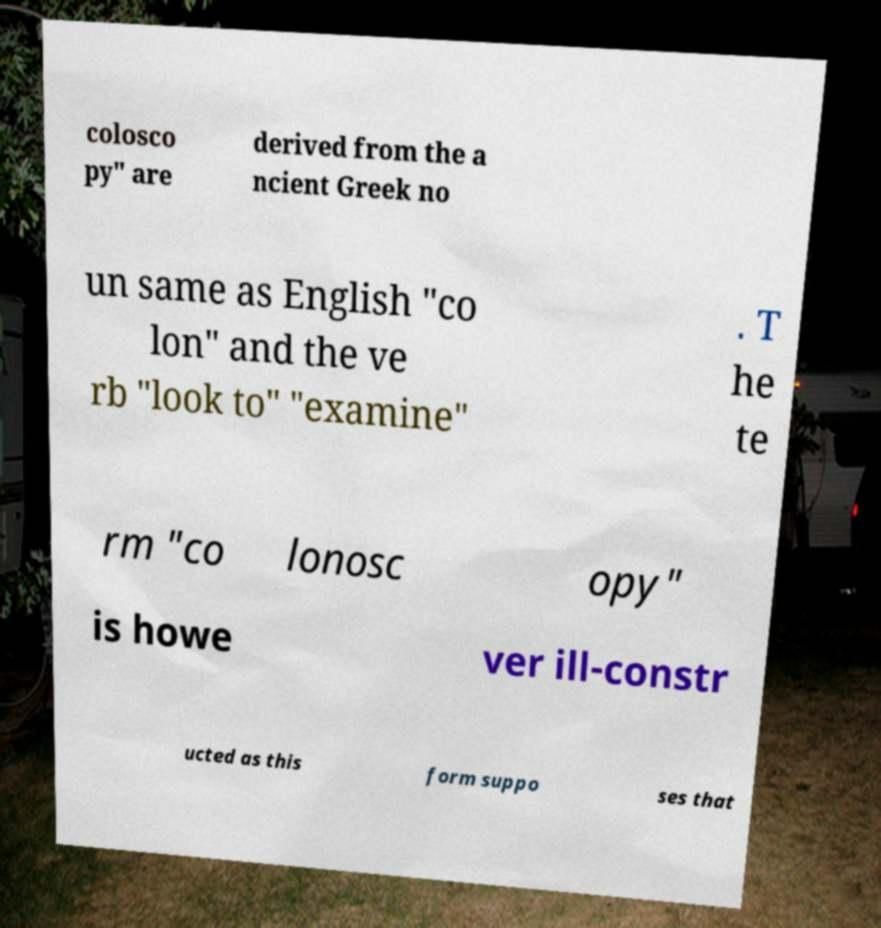Can you read and provide the text displayed in the image?This photo seems to have some interesting text. Can you extract and type it out for me? colosco py" are derived from the a ncient Greek no un same as English "co lon" and the ve rb "look to" "examine" . T he te rm "co lonosc opy" is howe ver ill-constr ucted as this form suppo ses that 